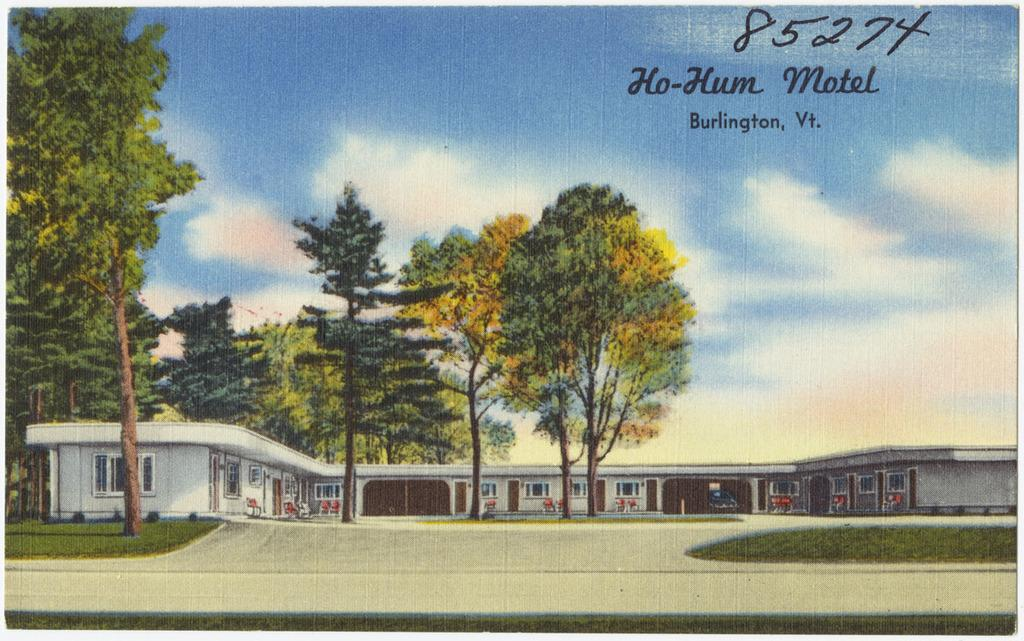Provide a one-sentence caption for the provided image. If you have never visited the Ho-Hum Motel in Burlington, Vt, you should. 